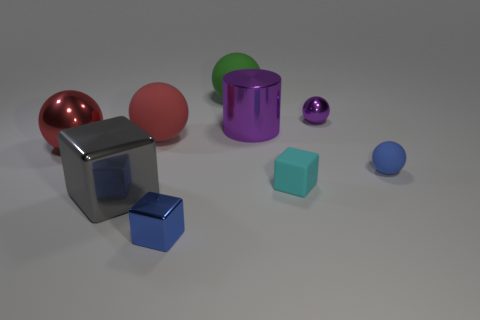What is the size of the sphere that is both behind the large metal sphere and right of the purple cylinder?
Keep it short and to the point. Small. There is a red matte thing; what number of shiny cylinders are on the left side of it?
Keep it short and to the point. 0. There is a thing that is on the left side of the blue metallic object and to the right of the big gray thing; what shape is it?
Offer a terse response. Sphere. There is another ball that is the same color as the big metallic sphere; what is it made of?
Your answer should be compact. Rubber. How many cylinders are either large shiny objects or small blue matte objects?
Your answer should be compact. 1. What size is the metal thing that is the same color as the tiny metallic sphere?
Provide a short and direct response. Large. Is the number of large red metal things behind the big shiny sphere less than the number of small metal cubes?
Make the answer very short. Yes. There is a ball that is on the right side of the green object and in front of the big red matte object; what color is it?
Provide a succinct answer. Blue. How many other things are there of the same shape as the small purple shiny object?
Your response must be concise. 4. Are there fewer purple objects that are left of the gray cube than tiny matte objects to the right of the matte block?
Your response must be concise. Yes. 